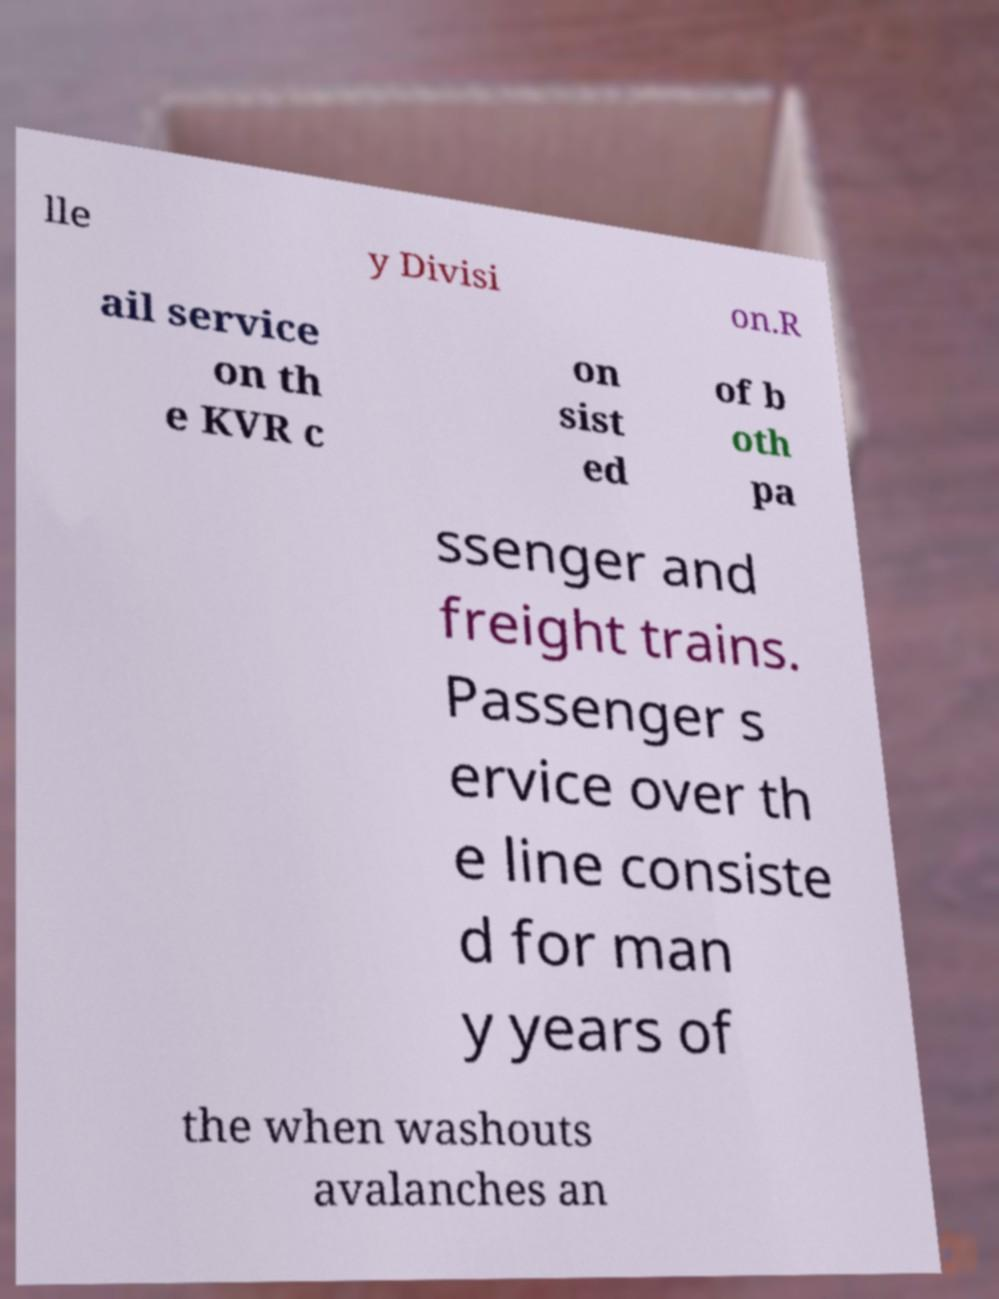Could you extract and type out the text from this image? lle y Divisi on.R ail service on th e KVR c on sist ed of b oth pa ssenger and freight trains. Passenger s ervice over th e line consiste d for man y years of the when washouts avalanches an 